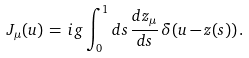Convert formula to latex. <formula><loc_0><loc_0><loc_500><loc_500>J _ { \mu } ( u ) \, = \, i g \int _ { 0 } ^ { 1 } d s \, \frac { d z _ { \mu } } { d s } \, \delta ( u - z ( s ) ) \, .</formula> 